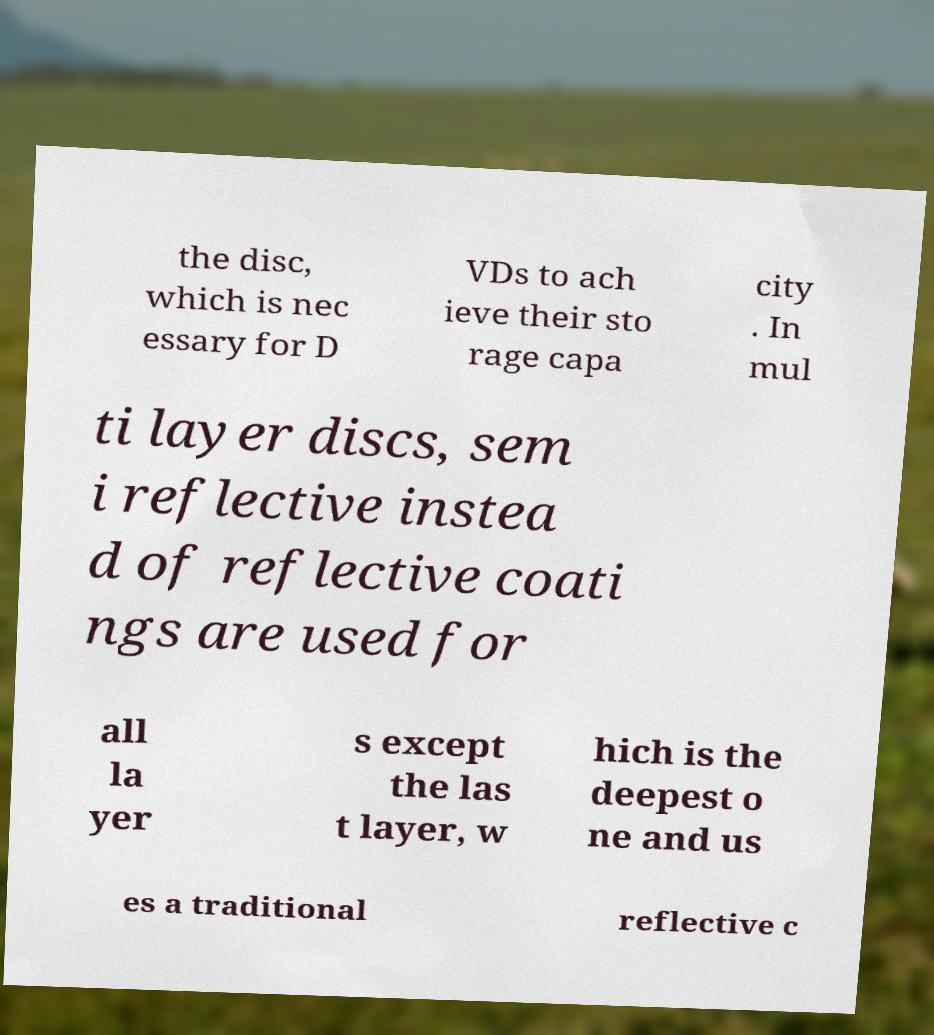Can you accurately transcribe the text from the provided image for me? the disc, which is nec essary for D VDs to ach ieve their sto rage capa city . In mul ti layer discs, sem i reflective instea d of reflective coati ngs are used for all la yer s except the las t layer, w hich is the deepest o ne and us es a traditional reflective c 